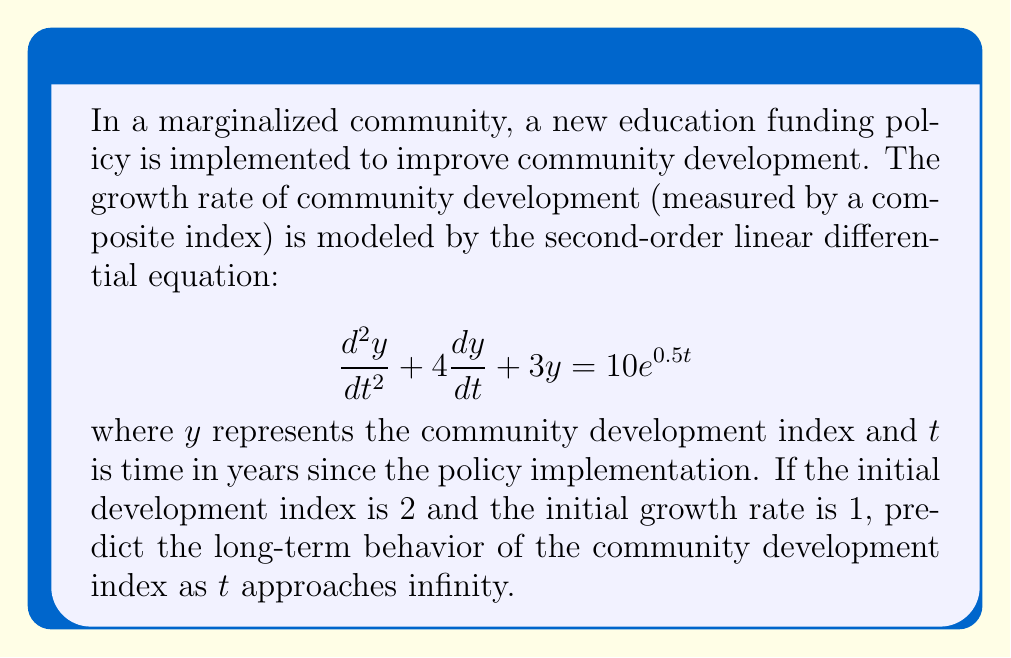Can you solve this math problem? To solve this problem, we need to follow these steps:

1) First, we need to find the general solution to the homogeneous equation:
   $$\frac{d^2y}{dt^2} + 4\frac{dy}{dt} + 3y = 0$$

   The characteristic equation is $r^2 + 4r + 3 = 0$
   Solving this, we get $r = -1$ or $r = -3$

   So, the homogeneous solution is $y_h = c_1e^{-t} + c_2e^{-3t}$

2) Next, we need to find a particular solution to the non-homogeneous equation. 
   Given the right-hand side is $10e^{0.5t}$, we guess a particular solution of the form:
   $y_p = Ae^{0.5t}$

   Substituting this into the original equation:
   $$(0.25A + 2A + 3A)e^{0.5t} = 10e^{0.5t}$$
   $$5.25A = 10$$
   $$A = \frac{10}{5.25} = \frac{40}{21}$$

   So, the particular solution is $y_p = \frac{40}{21}e^{0.5t}$

3) The general solution is the sum of the homogeneous and particular solutions:
   $$y = c_1e^{-t} + c_2e^{-3t} + \frac{40}{21}e^{0.5t}$$

4) To find the long-term behavior, we observe that as $t$ approaches infinity:
   - $e^{-t}$ and $e^{-3t}$ approach 0
   - $e^{0.5t}$ grows exponentially

   Therefore, the long-term behavior is dominated by the term $\frac{40}{21}e^{0.5t}$

5) We don't need to solve for $c_1$ and $c_2$ using the initial conditions, as they don't affect the long-term behavior.
Answer: As $t$ approaches infinity, the community development index will grow exponentially, approximated by the function $y \approx \frac{40}{21}e^{0.5t}$. 